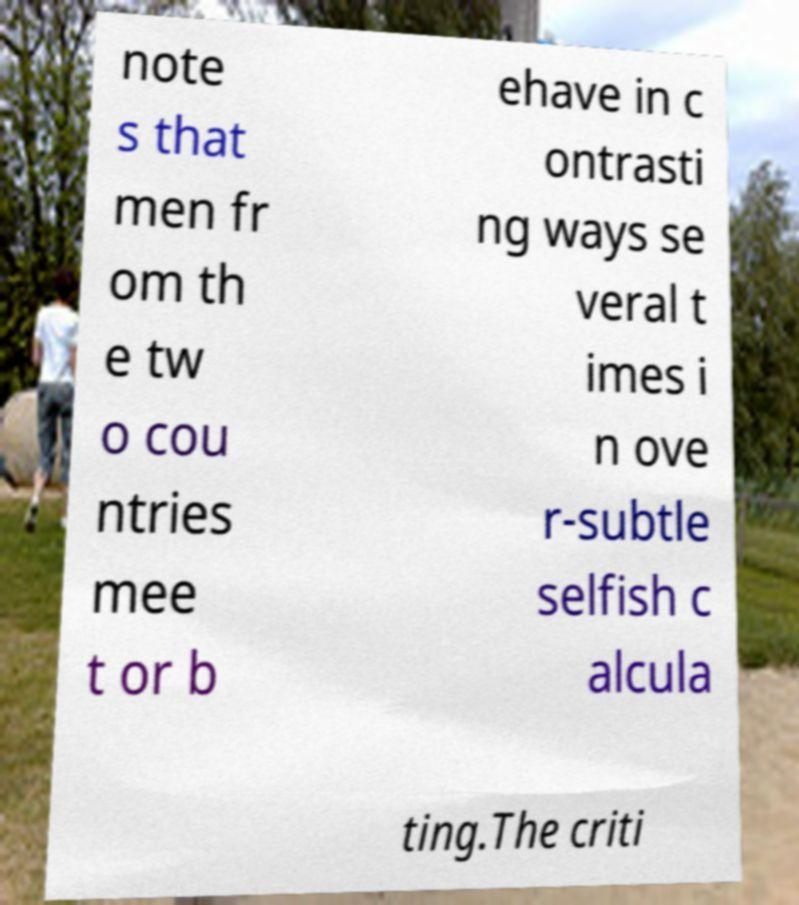Please read and relay the text visible in this image. What does it say? note s that men fr om th e tw o cou ntries mee t or b ehave in c ontrasti ng ways se veral t imes i n ove r-subtle selfish c alcula ting.The criti 